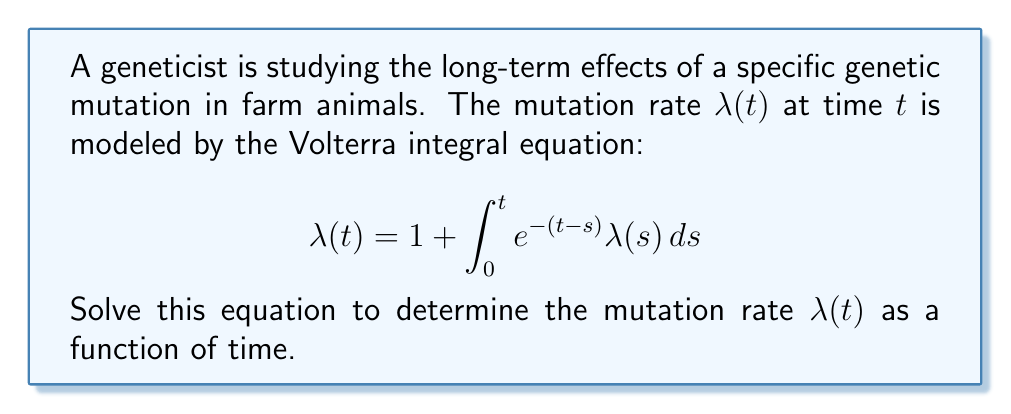Help me with this question. To solve this Volterra integral equation, we'll use the Laplace transform method:

1) Take the Laplace transform of both sides:
   $$\mathcal{L}\{\lambda(t)\} = \mathcal{L}\{1\} + \mathcal{L}\{\int_0^t e^{-(t-s)} \lambda(s) ds\}$$

2) Let $\Lambda(s)$ be the Laplace transform of $\lambda(t)$. Using Laplace transform properties:
   $$\Lambda(s) = \frac{1}{s} + \mathcal{L}\{e^{-t}\} \cdot \Lambda(s)$$

3) Simplify using the Laplace transform of $e^{-t}$:
   $$\Lambda(s) = \frac{1}{s} + \frac{1}{s+1} \Lambda(s)$$

4) Solve for $\Lambda(s)$:
   $$\Lambda(s) - \frac{1}{s+1} \Lambda(s) = \frac{1}{s}$$
   $$\Lambda(s) \cdot \frac{s}{s+1} = \frac{1}{s}$$
   $$\Lambda(s) = \frac{s+1}{s^2}$$

5) Take the inverse Laplace transform:
   $$\lambda(t) = \mathcal{L}^{-1}\{\frac{s+1}{s^2}\} = 1 + t$$

Therefore, the mutation rate $\lambda(t)$ increases linearly with time.
Answer: $\lambda(t) = 1 + t$ 